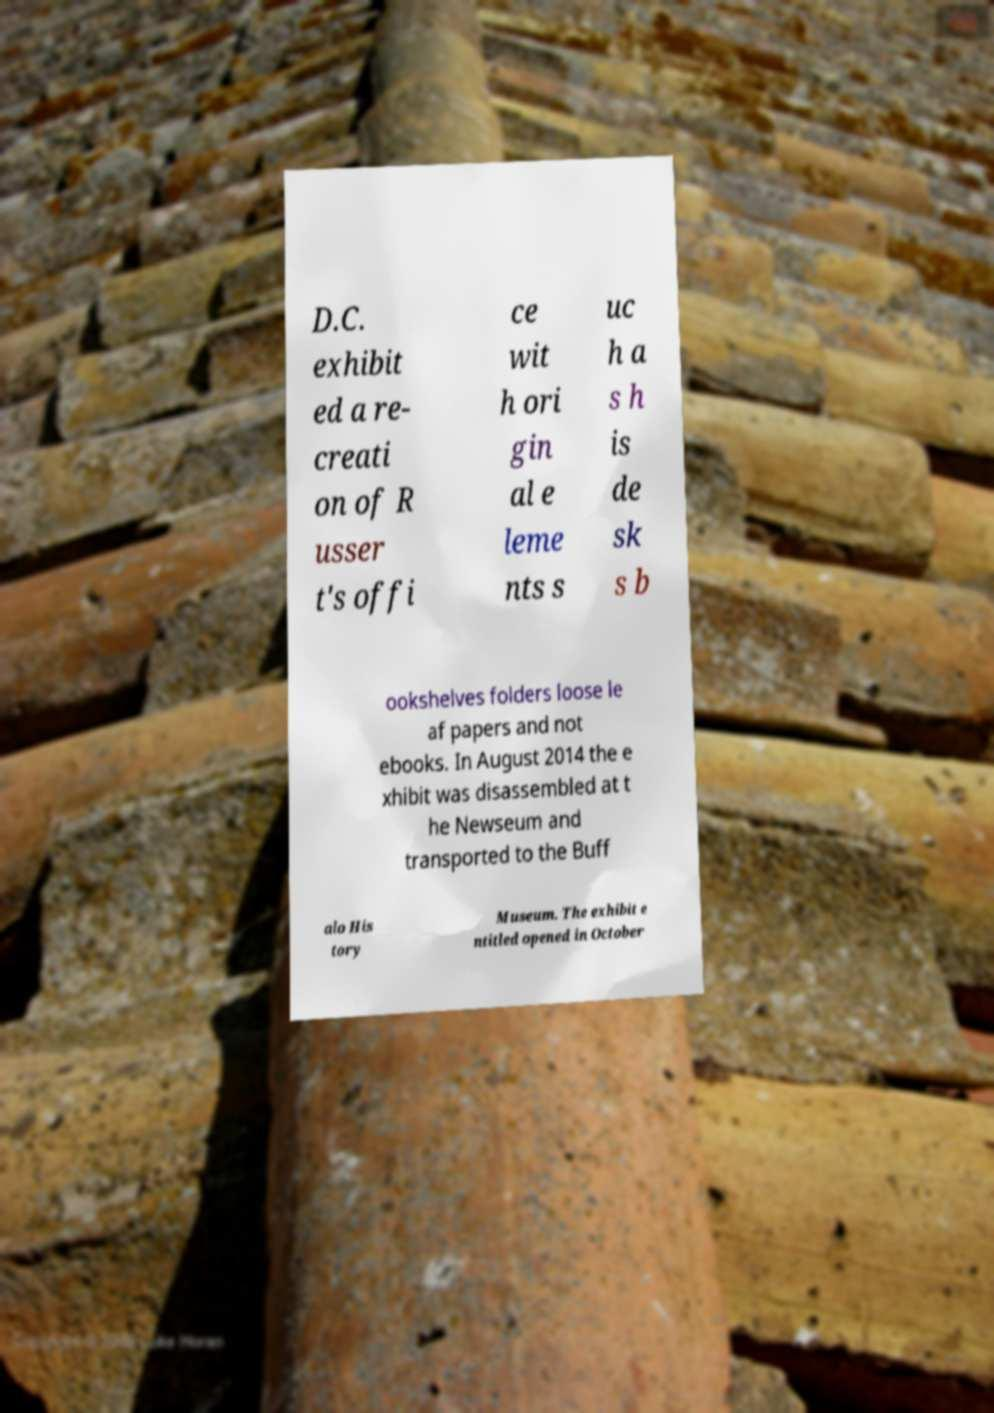Can you read and provide the text displayed in the image?This photo seems to have some interesting text. Can you extract and type it out for me? D.C. exhibit ed a re- creati on of R usser t's offi ce wit h ori gin al e leme nts s uc h a s h is de sk s b ookshelves folders loose le af papers and not ebooks. In August 2014 the e xhibit was disassembled at t he Newseum and transported to the Buff alo His tory Museum. The exhibit e ntitled opened in October 